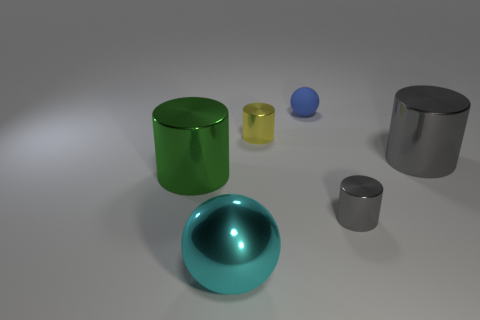Add 2 small shiny cylinders. How many objects exist? 8 Subtract all green cylinders. Subtract all gray cubes. How many cylinders are left? 3 Subtract all cylinders. How many objects are left? 2 Add 1 small cylinders. How many small cylinders exist? 3 Subtract 1 green cylinders. How many objects are left? 5 Subtract all large brown objects. Subtract all large gray objects. How many objects are left? 5 Add 5 tiny cylinders. How many tiny cylinders are left? 7 